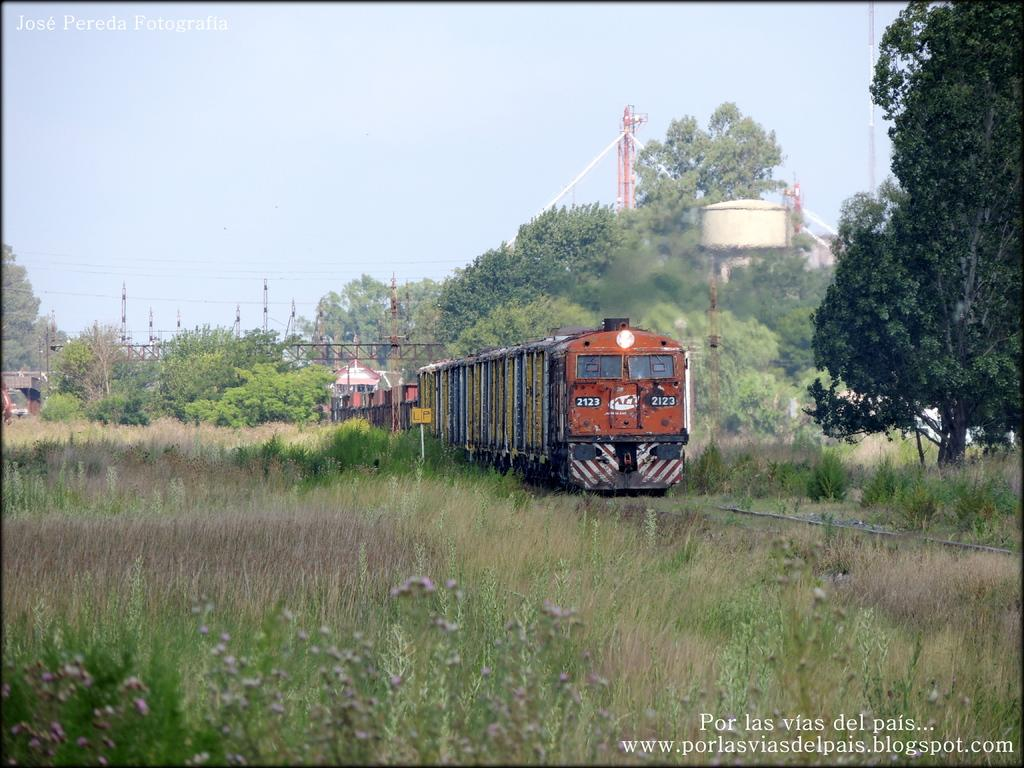<image>
Present a compact description of the photo's key features. a jose pereda photograph of a train in a field 